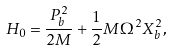Convert formula to latex. <formula><loc_0><loc_0><loc_500><loc_500>H _ { 0 } = \frac { P _ { b } ^ { 2 } } { 2 M } + \frac { 1 } { 2 } M \Omega ^ { 2 } X _ { b } ^ { 2 } ,</formula> 